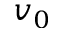Convert formula to latex. <formula><loc_0><loc_0><loc_500><loc_500>v _ { 0 }</formula> 